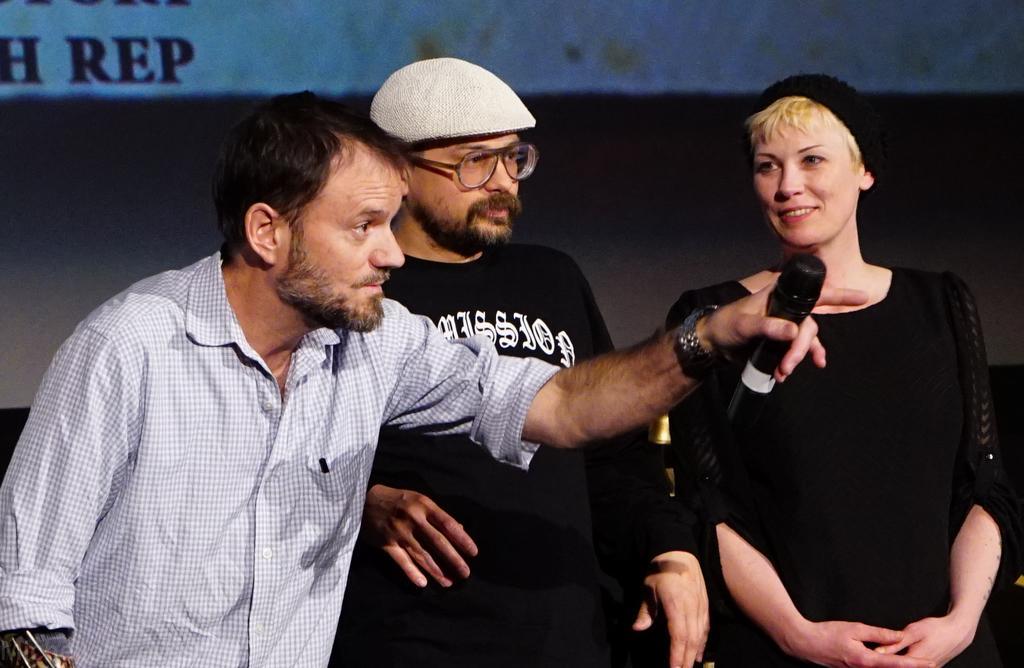How would you summarize this image in a sentence or two? In the image there are two men and women standing in the front and man on the left side holding a mic and behind them there is a screen on the wall. 